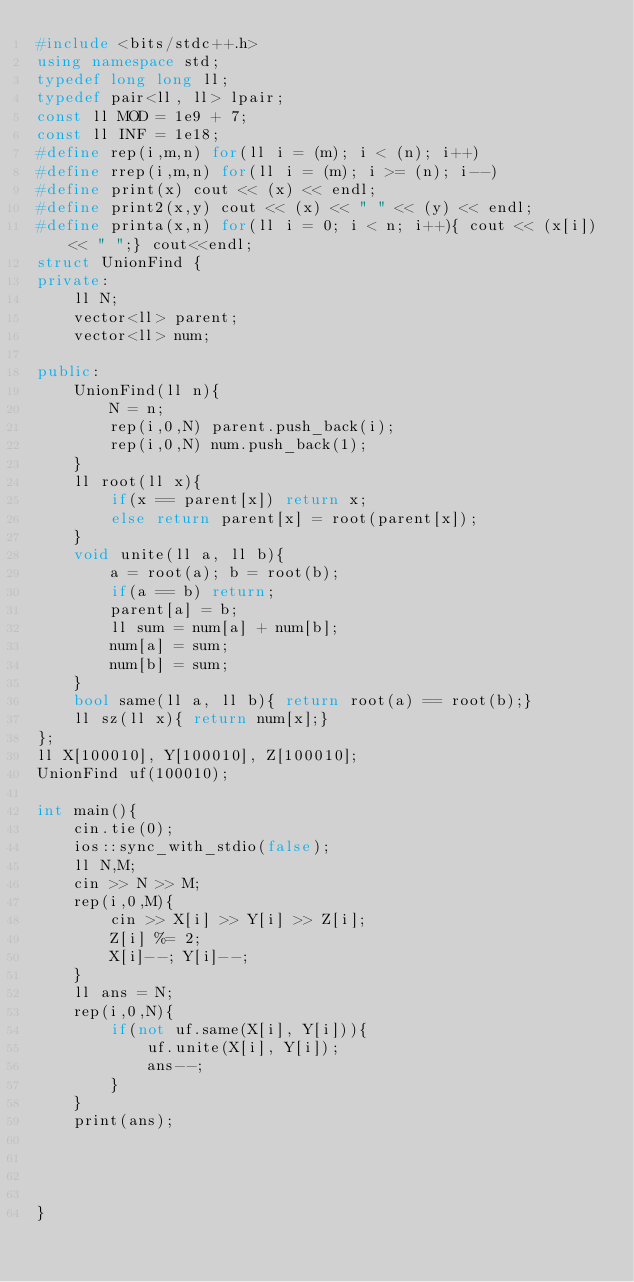Convert code to text. <code><loc_0><loc_0><loc_500><loc_500><_C++_>#include <bits/stdc++.h>
using namespace std;
typedef long long ll;
typedef pair<ll, ll> lpair;
const ll MOD = 1e9 + 7;
const ll INF = 1e18;
#define rep(i,m,n) for(ll i = (m); i < (n); i++)
#define rrep(i,m,n) for(ll i = (m); i >= (n); i--)
#define print(x) cout << (x) << endl;
#define print2(x,y) cout << (x) << " " << (y) << endl;
#define printa(x,n) for(ll i = 0; i < n; i++){ cout << (x[i]) << " ";} cout<<endl;
struct UnionFind {
private:
    ll N;
    vector<ll> parent;
    vector<ll> num;

public:
    UnionFind(ll n){
        N = n;
        rep(i,0,N) parent.push_back(i);
        rep(i,0,N) num.push_back(1);
    }
    ll root(ll x){
        if(x == parent[x]) return x;
        else return parent[x] = root(parent[x]);
    }
    void unite(ll a, ll b){
        a = root(a); b = root(b);
        if(a == b) return;
        parent[a] = b;
        ll sum = num[a] + num[b];
        num[a] = sum;
        num[b] = sum;
    }
    bool same(ll a, ll b){ return root(a) == root(b);}
    ll sz(ll x){ return num[x];}
};
ll X[100010], Y[100010], Z[100010];
UnionFind uf(100010);

int main(){
    cin.tie(0);
    ios::sync_with_stdio(false);
    ll N,M;
    cin >> N >> M;
    rep(i,0,M){
        cin >> X[i] >> Y[i] >> Z[i];
        Z[i] %= 2;
        X[i]--; Y[i]--;
    }
    ll ans = N;
    rep(i,0,N){
        if(not uf.same(X[i], Y[i])){
            uf.unite(X[i], Y[i]);
            ans--;
        }
    }
    print(ans);




}</code> 